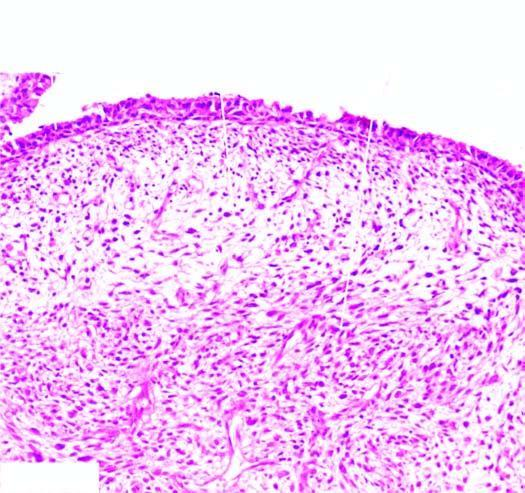does the tumour show the characteristic submucosal cambium layer of tumour cells?
Answer the question using a single word or phrase. Yes 